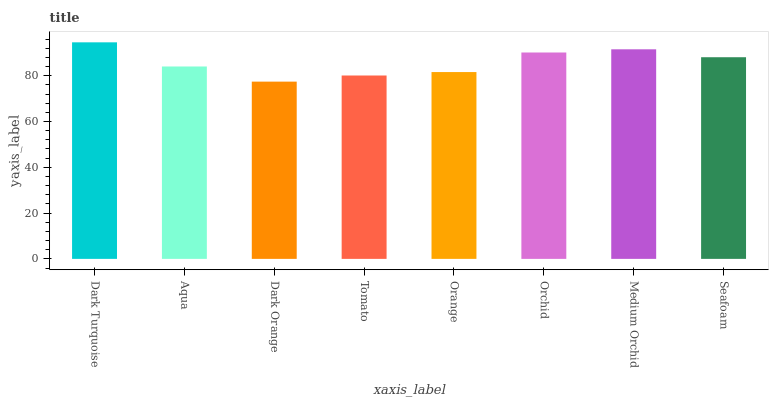Is Dark Orange the minimum?
Answer yes or no. Yes. Is Dark Turquoise the maximum?
Answer yes or no. Yes. Is Aqua the minimum?
Answer yes or no. No. Is Aqua the maximum?
Answer yes or no. No. Is Dark Turquoise greater than Aqua?
Answer yes or no. Yes. Is Aqua less than Dark Turquoise?
Answer yes or no. Yes. Is Aqua greater than Dark Turquoise?
Answer yes or no. No. Is Dark Turquoise less than Aqua?
Answer yes or no. No. Is Seafoam the high median?
Answer yes or no. Yes. Is Aqua the low median?
Answer yes or no. Yes. Is Orchid the high median?
Answer yes or no. No. Is Orange the low median?
Answer yes or no. No. 